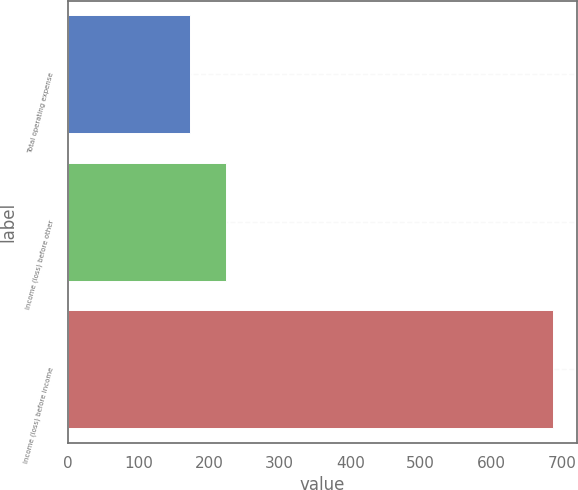<chart> <loc_0><loc_0><loc_500><loc_500><bar_chart><fcel>Total operating expense<fcel>Income (loss) before other<fcel>Income (loss) before income<nl><fcel>173<fcel>224.4<fcel>687<nl></chart> 